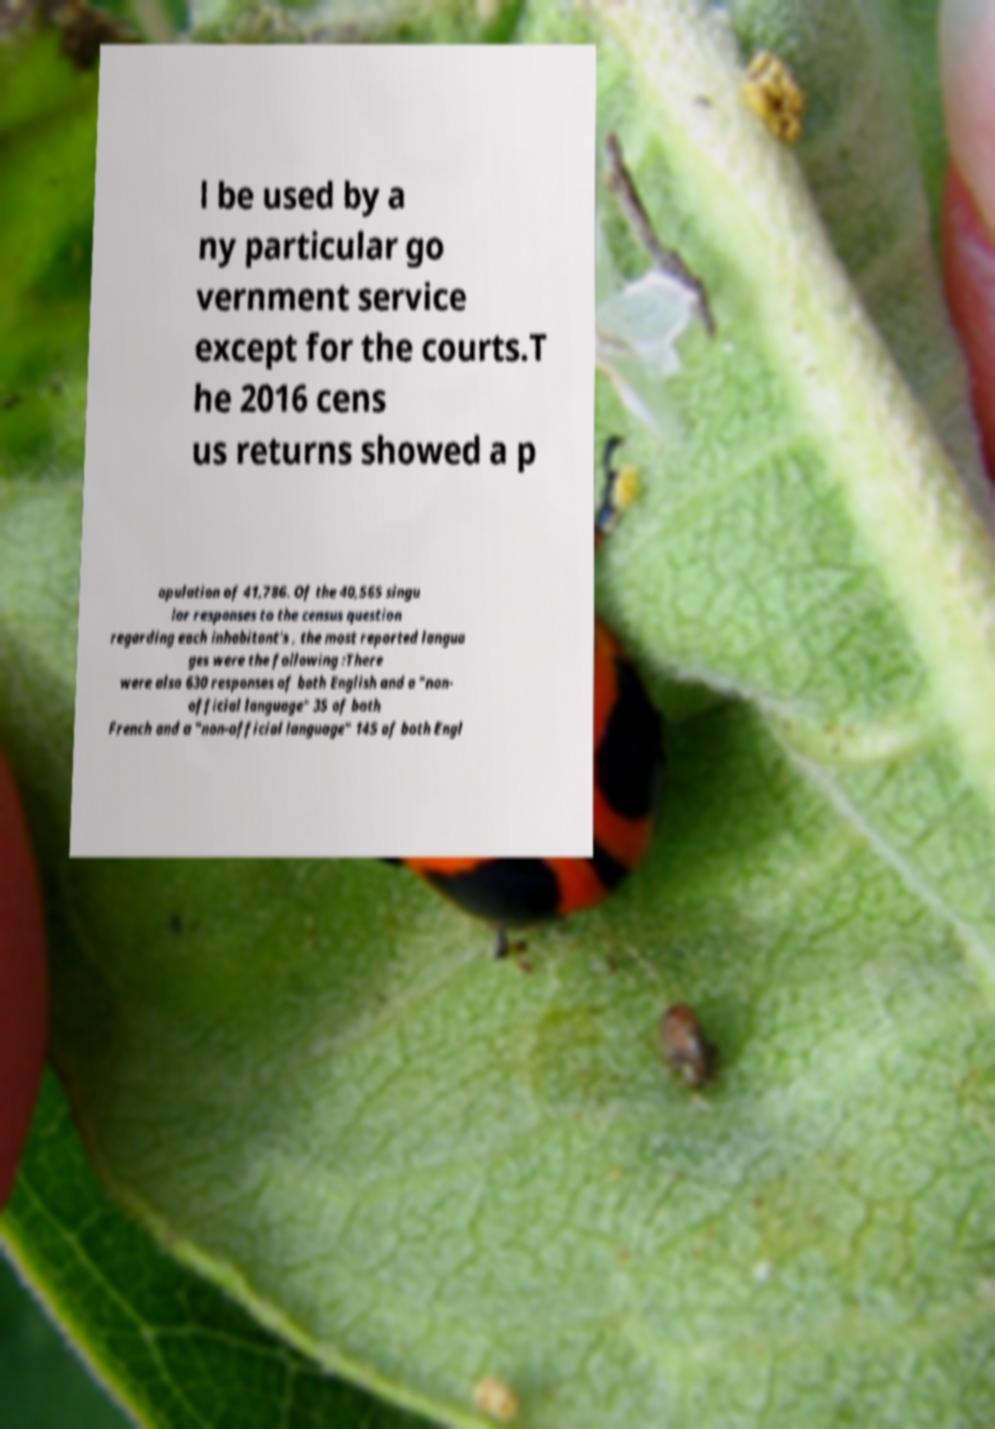There's text embedded in this image that I need extracted. Can you transcribe it verbatim? l be used by a ny particular go vernment service except for the courts.T he 2016 cens us returns showed a p opulation of 41,786. Of the 40,565 singu lar responses to the census question regarding each inhabitant's , the most reported langua ges were the following :There were also 630 responses of both English and a "non- official language" 35 of both French and a "non-official language" 145 of both Engl 